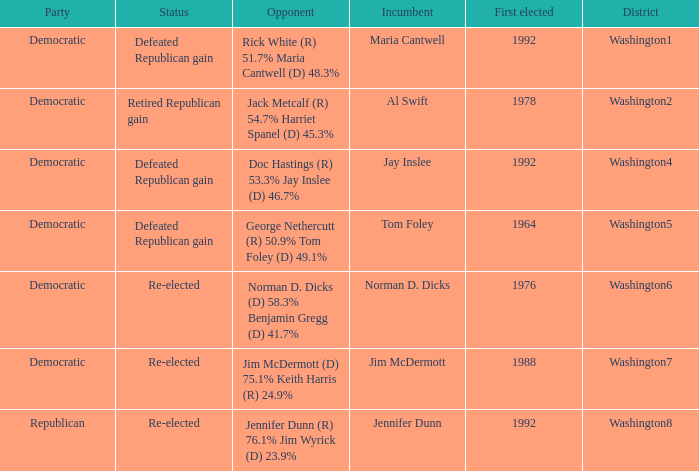What year was incumbent jim mcdermott first elected? 1988.0. 